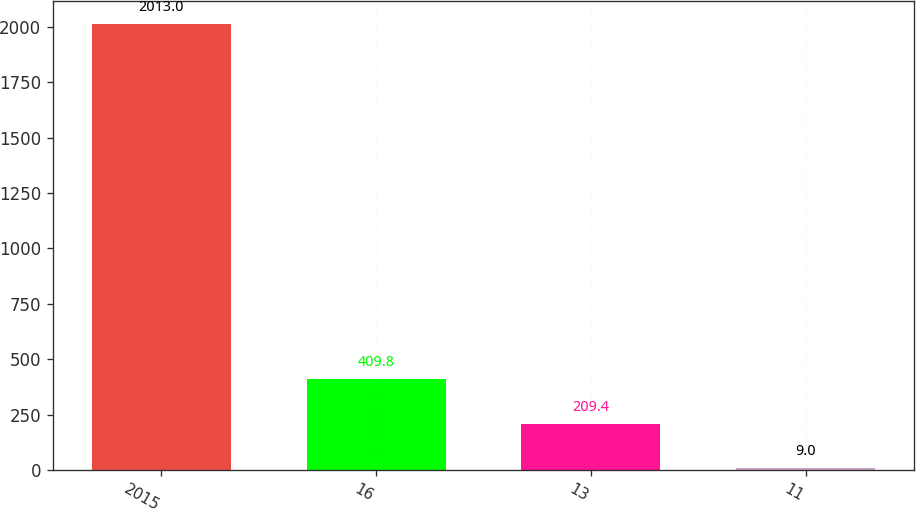Convert chart to OTSL. <chart><loc_0><loc_0><loc_500><loc_500><bar_chart><fcel>2015<fcel>16<fcel>13<fcel>11<nl><fcel>2013<fcel>409.8<fcel>209.4<fcel>9<nl></chart> 